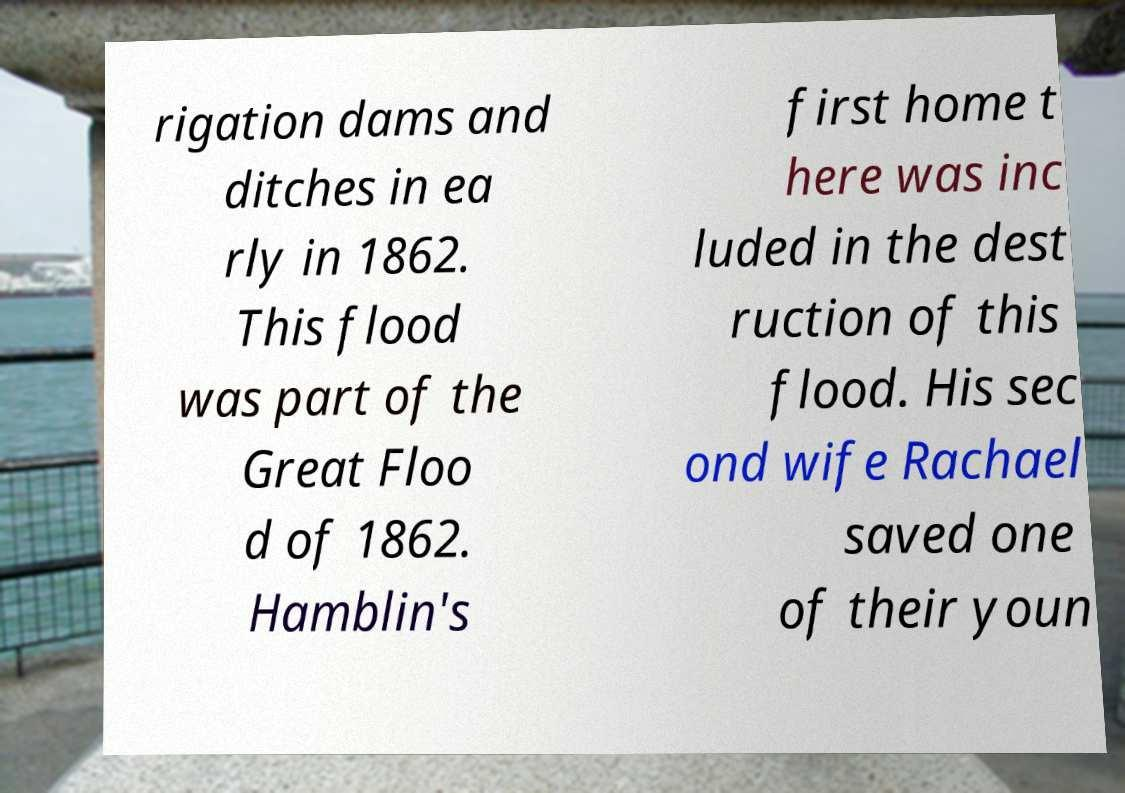Can you accurately transcribe the text from the provided image for me? rigation dams and ditches in ea rly in 1862. This flood was part of the Great Floo d of 1862. Hamblin's first home t here was inc luded in the dest ruction of this flood. His sec ond wife Rachael saved one of their youn 